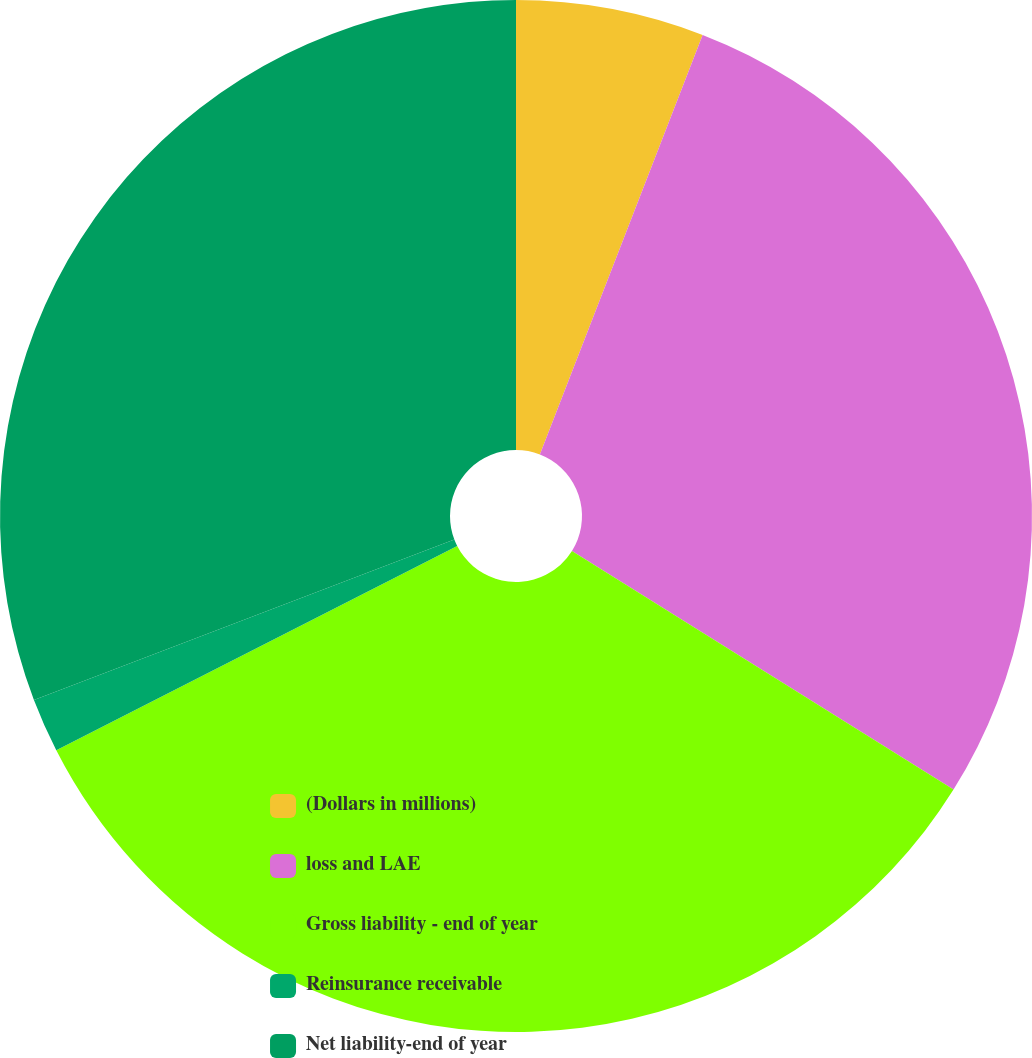<chart> <loc_0><loc_0><loc_500><loc_500><pie_chart><fcel>(Dollars in millions)<fcel>loss and LAE<fcel>Gross liability - end of year<fcel>Reinsurance receivable<fcel>Net liability-end of year<nl><fcel>5.89%<fcel>28.0%<fcel>33.6%<fcel>1.7%<fcel>30.8%<nl></chart> 